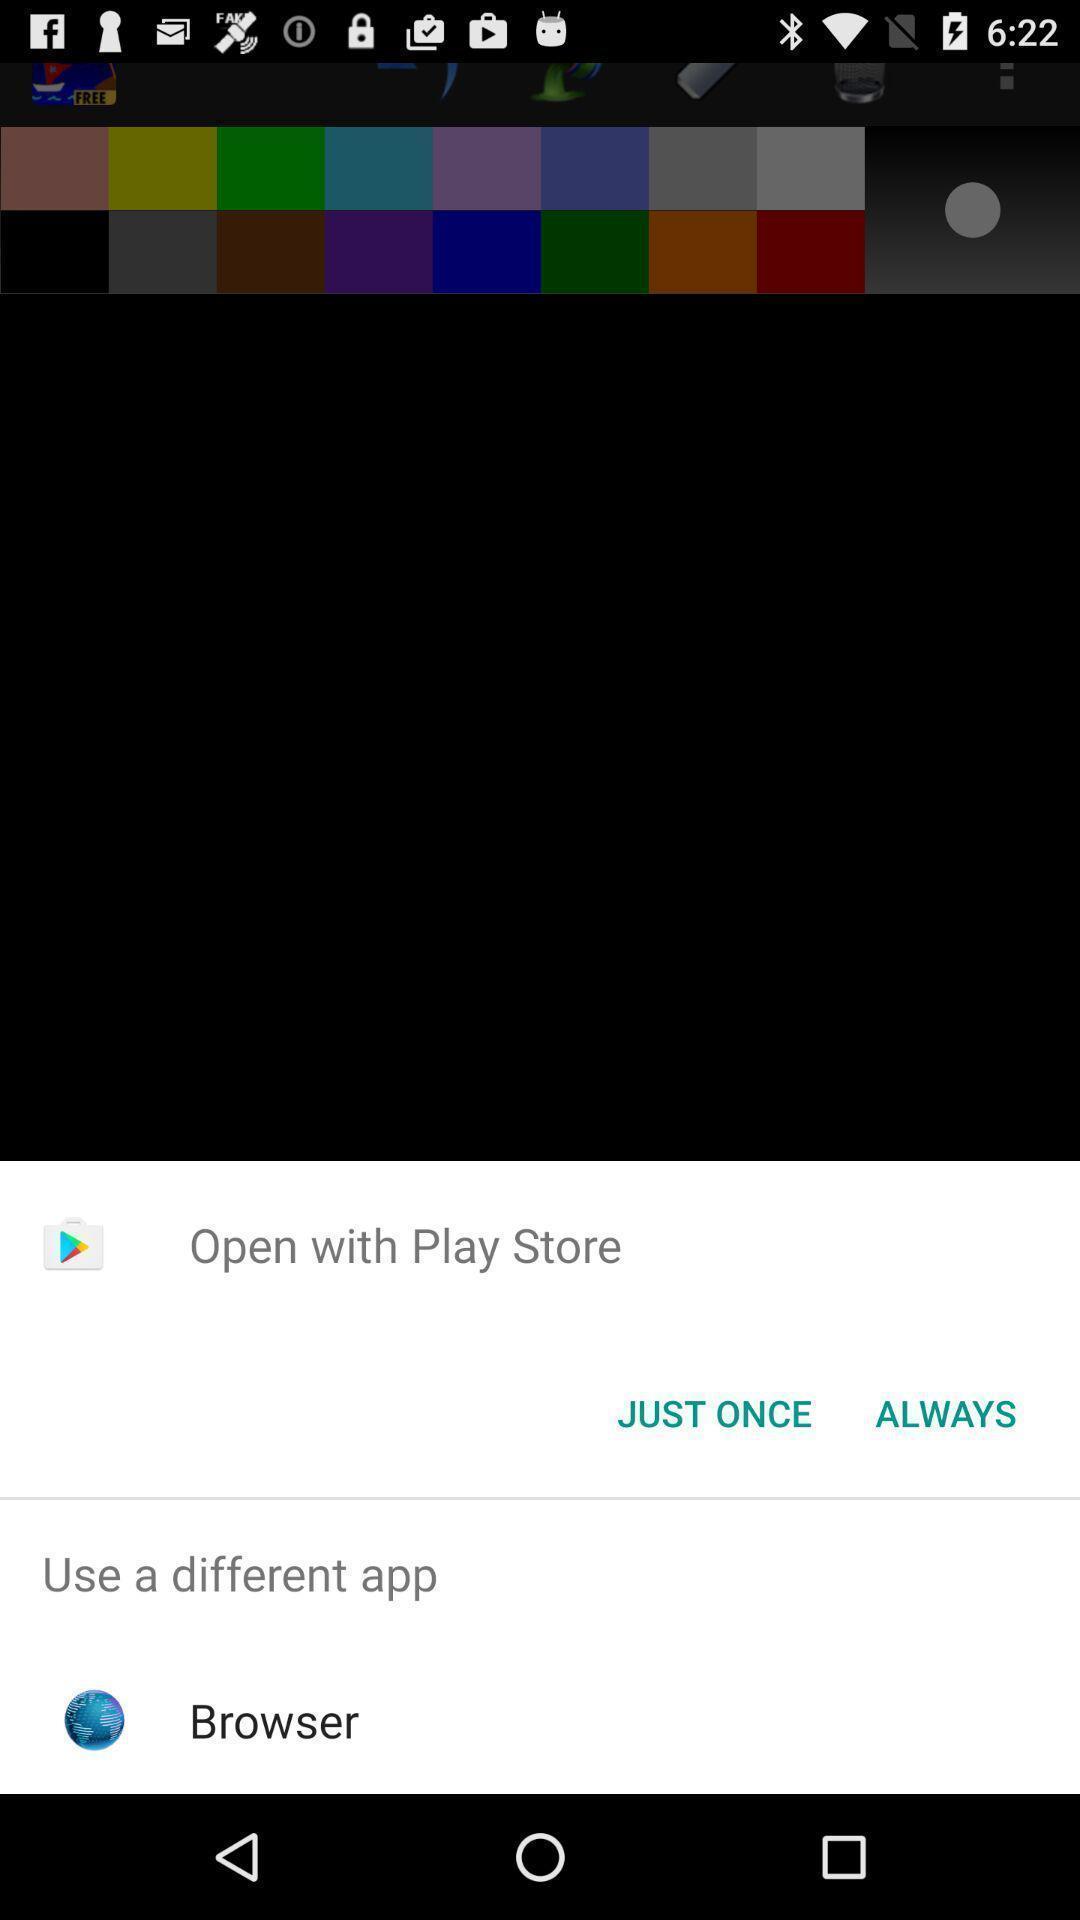Summarize the information in this screenshot. Pop-up with options to open a link. 